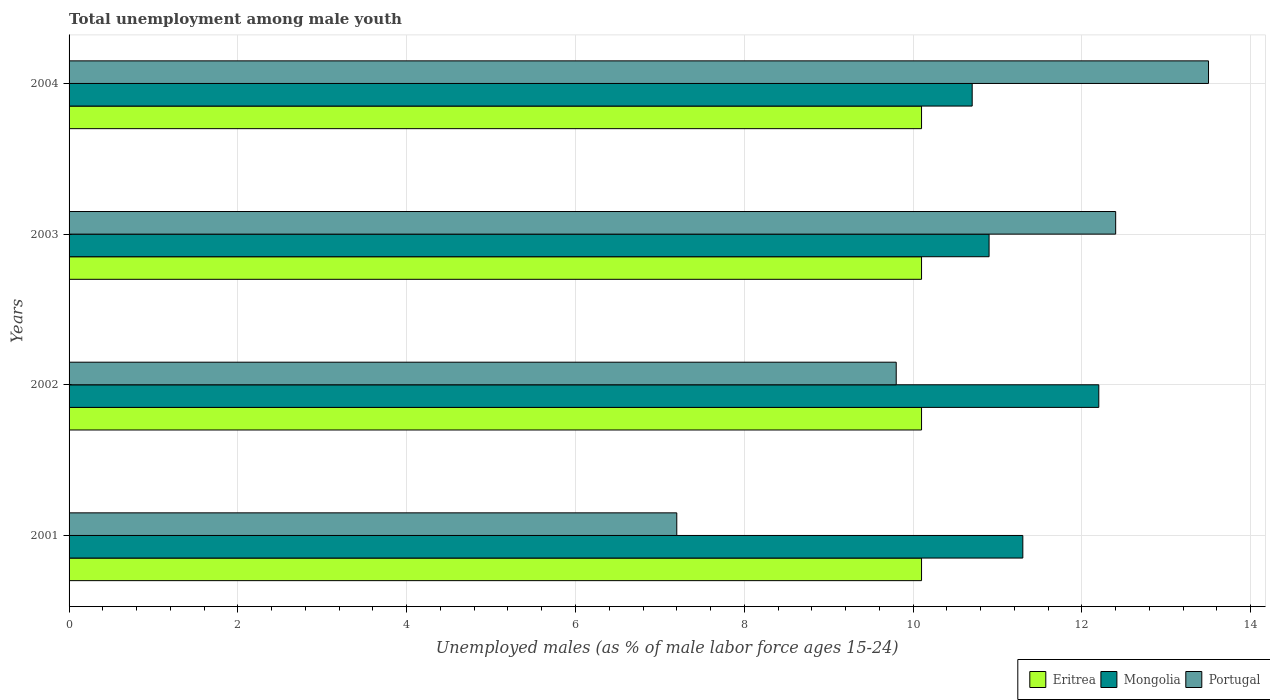How many different coloured bars are there?
Keep it short and to the point. 3. Are the number of bars per tick equal to the number of legend labels?
Offer a terse response. Yes. How many bars are there on the 1st tick from the top?
Ensure brevity in your answer.  3. How many bars are there on the 4th tick from the bottom?
Give a very brief answer. 3. What is the label of the 3rd group of bars from the top?
Provide a succinct answer. 2002. In how many cases, is the number of bars for a given year not equal to the number of legend labels?
Give a very brief answer. 0. What is the percentage of unemployed males in in Mongolia in 2003?
Your answer should be compact. 10.9. Across all years, what is the maximum percentage of unemployed males in in Portugal?
Ensure brevity in your answer.  13.5. Across all years, what is the minimum percentage of unemployed males in in Portugal?
Provide a short and direct response. 7.2. What is the total percentage of unemployed males in in Eritrea in the graph?
Make the answer very short. 40.4. What is the difference between the percentage of unemployed males in in Portugal in 2004 and the percentage of unemployed males in in Eritrea in 2001?
Ensure brevity in your answer.  3.4. What is the average percentage of unemployed males in in Mongolia per year?
Your response must be concise. 11.27. In the year 2002, what is the difference between the percentage of unemployed males in in Mongolia and percentage of unemployed males in in Portugal?
Give a very brief answer. 2.4. In how many years, is the percentage of unemployed males in in Eritrea greater than 2 %?
Your answer should be very brief. 4. What is the ratio of the percentage of unemployed males in in Eritrea in 2001 to that in 2004?
Make the answer very short. 1. What is the difference between the highest and the second highest percentage of unemployed males in in Portugal?
Your response must be concise. 1.1. In how many years, is the percentage of unemployed males in in Eritrea greater than the average percentage of unemployed males in in Eritrea taken over all years?
Offer a very short reply. 0. What does the 3rd bar from the top in 2002 represents?
Give a very brief answer. Eritrea. What does the 1st bar from the bottom in 2004 represents?
Keep it short and to the point. Eritrea. Is it the case that in every year, the sum of the percentage of unemployed males in in Portugal and percentage of unemployed males in in Eritrea is greater than the percentage of unemployed males in in Mongolia?
Your answer should be very brief. Yes. How many bars are there?
Your answer should be very brief. 12. How many years are there in the graph?
Give a very brief answer. 4. Does the graph contain any zero values?
Give a very brief answer. No. Does the graph contain grids?
Make the answer very short. Yes. What is the title of the graph?
Your answer should be very brief. Total unemployment among male youth. Does "Switzerland" appear as one of the legend labels in the graph?
Your answer should be very brief. No. What is the label or title of the X-axis?
Offer a terse response. Unemployed males (as % of male labor force ages 15-24). What is the label or title of the Y-axis?
Ensure brevity in your answer.  Years. What is the Unemployed males (as % of male labor force ages 15-24) of Eritrea in 2001?
Provide a short and direct response. 10.1. What is the Unemployed males (as % of male labor force ages 15-24) in Mongolia in 2001?
Provide a succinct answer. 11.3. What is the Unemployed males (as % of male labor force ages 15-24) of Portugal in 2001?
Make the answer very short. 7.2. What is the Unemployed males (as % of male labor force ages 15-24) of Eritrea in 2002?
Offer a very short reply. 10.1. What is the Unemployed males (as % of male labor force ages 15-24) in Mongolia in 2002?
Your answer should be compact. 12.2. What is the Unemployed males (as % of male labor force ages 15-24) of Portugal in 2002?
Your response must be concise. 9.8. What is the Unemployed males (as % of male labor force ages 15-24) of Eritrea in 2003?
Ensure brevity in your answer.  10.1. What is the Unemployed males (as % of male labor force ages 15-24) in Mongolia in 2003?
Keep it short and to the point. 10.9. What is the Unemployed males (as % of male labor force ages 15-24) in Portugal in 2003?
Keep it short and to the point. 12.4. What is the Unemployed males (as % of male labor force ages 15-24) of Eritrea in 2004?
Your response must be concise. 10.1. What is the Unemployed males (as % of male labor force ages 15-24) of Mongolia in 2004?
Provide a succinct answer. 10.7. Across all years, what is the maximum Unemployed males (as % of male labor force ages 15-24) of Eritrea?
Provide a succinct answer. 10.1. Across all years, what is the maximum Unemployed males (as % of male labor force ages 15-24) of Mongolia?
Offer a very short reply. 12.2. Across all years, what is the minimum Unemployed males (as % of male labor force ages 15-24) in Eritrea?
Your answer should be very brief. 10.1. Across all years, what is the minimum Unemployed males (as % of male labor force ages 15-24) in Mongolia?
Make the answer very short. 10.7. Across all years, what is the minimum Unemployed males (as % of male labor force ages 15-24) of Portugal?
Give a very brief answer. 7.2. What is the total Unemployed males (as % of male labor force ages 15-24) in Eritrea in the graph?
Keep it short and to the point. 40.4. What is the total Unemployed males (as % of male labor force ages 15-24) of Mongolia in the graph?
Make the answer very short. 45.1. What is the total Unemployed males (as % of male labor force ages 15-24) of Portugal in the graph?
Make the answer very short. 42.9. What is the difference between the Unemployed males (as % of male labor force ages 15-24) of Mongolia in 2001 and that in 2002?
Offer a terse response. -0.9. What is the difference between the Unemployed males (as % of male labor force ages 15-24) in Portugal in 2001 and that in 2003?
Provide a short and direct response. -5.2. What is the difference between the Unemployed males (as % of male labor force ages 15-24) in Portugal in 2001 and that in 2004?
Your response must be concise. -6.3. What is the difference between the Unemployed males (as % of male labor force ages 15-24) of Mongolia in 2002 and that in 2003?
Provide a succinct answer. 1.3. What is the difference between the Unemployed males (as % of male labor force ages 15-24) in Eritrea in 2002 and that in 2004?
Your answer should be very brief. 0. What is the difference between the Unemployed males (as % of male labor force ages 15-24) of Portugal in 2002 and that in 2004?
Provide a succinct answer. -3.7. What is the difference between the Unemployed males (as % of male labor force ages 15-24) of Mongolia in 2003 and that in 2004?
Your response must be concise. 0.2. What is the difference between the Unemployed males (as % of male labor force ages 15-24) in Eritrea in 2001 and the Unemployed males (as % of male labor force ages 15-24) in Mongolia in 2002?
Make the answer very short. -2.1. What is the difference between the Unemployed males (as % of male labor force ages 15-24) in Mongolia in 2001 and the Unemployed males (as % of male labor force ages 15-24) in Portugal in 2002?
Ensure brevity in your answer.  1.5. What is the difference between the Unemployed males (as % of male labor force ages 15-24) in Eritrea in 2001 and the Unemployed males (as % of male labor force ages 15-24) in Mongolia in 2003?
Provide a succinct answer. -0.8. What is the difference between the Unemployed males (as % of male labor force ages 15-24) in Eritrea in 2001 and the Unemployed males (as % of male labor force ages 15-24) in Portugal in 2003?
Ensure brevity in your answer.  -2.3. What is the difference between the Unemployed males (as % of male labor force ages 15-24) of Mongolia in 2001 and the Unemployed males (as % of male labor force ages 15-24) of Portugal in 2003?
Make the answer very short. -1.1. What is the difference between the Unemployed males (as % of male labor force ages 15-24) of Eritrea in 2002 and the Unemployed males (as % of male labor force ages 15-24) of Portugal in 2003?
Your answer should be very brief. -2.3. What is the difference between the Unemployed males (as % of male labor force ages 15-24) in Mongolia in 2002 and the Unemployed males (as % of male labor force ages 15-24) in Portugal in 2003?
Make the answer very short. -0.2. What is the difference between the Unemployed males (as % of male labor force ages 15-24) in Eritrea in 2003 and the Unemployed males (as % of male labor force ages 15-24) in Mongolia in 2004?
Provide a succinct answer. -0.6. What is the average Unemployed males (as % of male labor force ages 15-24) in Mongolia per year?
Give a very brief answer. 11.28. What is the average Unemployed males (as % of male labor force ages 15-24) in Portugal per year?
Offer a terse response. 10.72. In the year 2001, what is the difference between the Unemployed males (as % of male labor force ages 15-24) in Eritrea and Unemployed males (as % of male labor force ages 15-24) in Mongolia?
Make the answer very short. -1.2. In the year 2001, what is the difference between the Unemployed males (as % of male labor force ages 15-24) of Eritrea and Unemployed males (as % of male labor force ages 15-24) of Portugal?
Your answer should be compact. 2.9. In the year 2001, what is the difference between the Unemployed males (as % of male labor force ages 15-24) in Mongolia and Unemployed males (as % of male labor force ages 15-24) in Portugal?
Offer a terse response. 4.1. In the year 2002, what is the difference between the Unemployed males (as % of male labor force ages 15-24) in Eritrea and Unemployed males (as % of male labor force ages 15-24) in Mongolia?
Your answer should be compact. -2.1. In the year 2002, what is the difference between the Unemployed males (as % of male labor force ages 15-24) in Eritrea and Unemployed males (as % of male labor force ages 15-24) in Portugal?
Your answer should be very brief. 0.3. In the year 2002, what is the difference between the Unemployed males (as % of male labor force ages 15-24) in Mongolia and Unemployed males (as % of male labor force ages 15-24) in Portugal?
Offer a very short reply. 2.4. In the year 2003, what is the difference between the Unemployed males (as % of male labor force ages 15-24) of Eritrea and Unemployed males (as % of male labor force ages 15-24) of Mongolia?
Your answer should be very brief. -0.8. In the year 2003, what is the difference between the Unemployed males (as % of male labor force ages 15-24) in Mongolia and Unemployed males (as % of male labor force ages 15-24) in Portugal?
Your answer should be very brief. -1.5. In the year 2004, what is the difference between the Unemployed males (as % of male labor force ages 15-24) of Eritrea and Unemployed males (as % of male labor force ages 15-24) of Portugal?
Give a very brief answer. -3.4. In the year 2004, what is the difference between the Unemployed males (as % of male labor force ages 15-24) in Mongolia and Unemployed males (as % of male labor force ages 15-24) in Portugal?
Ensure brevity in your answer.  -2.8. What is the ratio of the Unemployed males (as % of male labor force ages 15-24) of Mongolia in 2001 to that in 2002?
Your answer should be very brief. 0.93. What is the ratio of the Unemployed males (as % of male labor force ages 15-24) of Portugal in 2001 to that in 2002?
Your answer should be compact. 0.73. What is the ratio of the Unemployed males (as % of male labor force ages 15-24) in Mongolia in 2001 to that in 2003?
Make the answer very short. 1.04. What is the ratio of the Unemployed males (as % of male labor force ages 15-24) in Portugal in 2001 to that in 2003?
Make the answer very short. 0.58. What is the ratio of the Unemployed males (as % of male labor force ages 15-24) in Mongolia in 2001 to that in 2004?
Provide a short and direct response. 1.06. What is the ratio of the Unemployed males (as % of male labor force ages 15-24) of Portugal in 2001 to that in 2004?
Offer a terse response. 0.53. What is the ratio of the Unemployed males (as % of male labor force ages 15-24) of Eritrea in 2002 to that in 2003?
Keep it short and to the point. 1. What is the ratio of the Unemployed males (as % of male labor force ages 15-24) in Mongolia in 2002 to that in 2003?
Offer a very short reply. 1.12. What is the ratio of the Unemployed males (as % of male labor force ages 15-24) in Portugal in 2002 to that in 2003?
Provide a succinct answer. 0.79. What is the ratio of the Unemployed males (as % of male labor force ages 15-24) of Eritrea in 2002 to that in 2004?
Keep it short and to the point. 1. What is the ratio of the Unemployed males (as % of male labor force ages 15-24) of Mongolia in 2002 to that in 2004?
Make the answer very short. 1.14. What is the ratio of the Unemployed males (as % of male labor force ages 15-24) of Portugal in 2002 to that in 2004?
Provide a succinct answer. 0.73. What is the ratio of the Unemployed males (as % of male labor force ages 15-24) of Mongolia in 2003 to that in 2004?
Give a very brief answer. 1.02. What is the ratio of the Unemployed males (as % of male labor force ages 15-24) of Portugal in 2003 to that in 2004?
Give a very brief answer. 0.92. What is the difference between the highest and the second highest Unemployed males (as % of male labor force ages 15-24) of Mongolia?
Your answer should be very brief. 0.9. What is the difference between the highest and the lowest Unemployed males (as % of male labor force ages 15-24) of Eritrea?
Give a very brief answer. 0. 